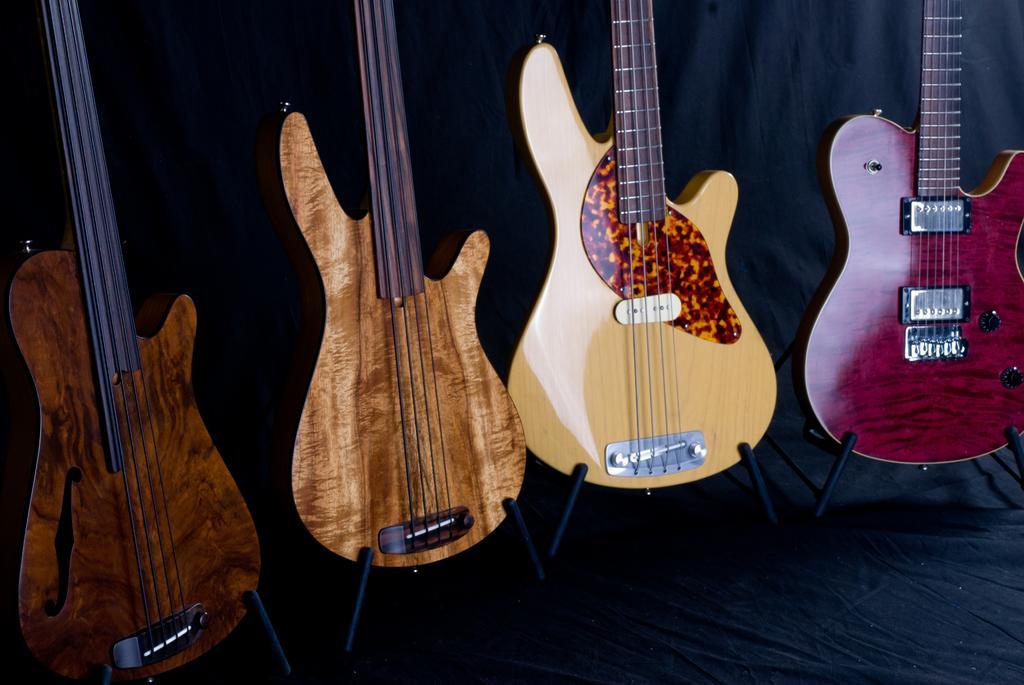In one or two sentences, can you explain what this image depicts? As we can see in the image there are four guitars. 